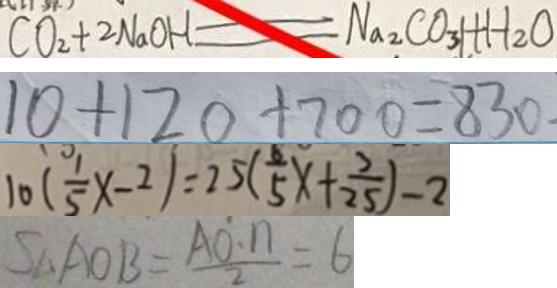Convert formula to latex. <formula><loc_0><loc_0><loc_500><loc_500>C O _ { 2 } + 2 N a O H = N a _ { 2 } C O _ { 3 } l + H _ { 2 } O 
 1 0 + 1 2 0 + 7 0 0 = 8 3 0 
 1 0 ( \frac { 1 } { 5 } x - 2 ) = 2 5 ( \frac { 8 } { 5 } x + \frac { 7 } { 2 5 } ) - 2 
 S _ { \Delta A O B } = \frac { A O \cdot n } { 2 } = 6</formula> 